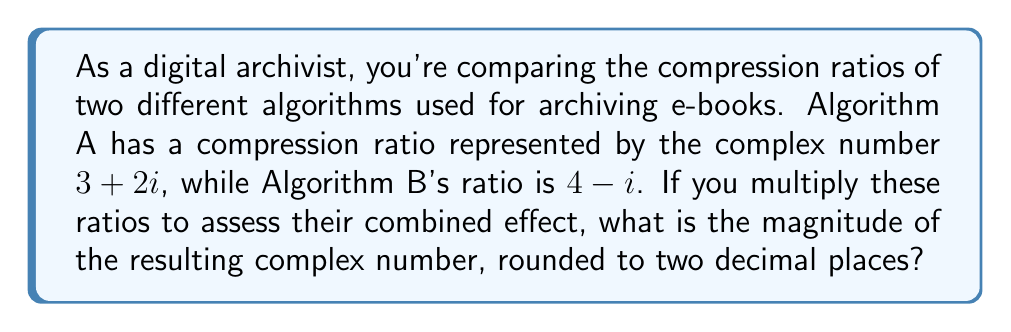Provide a solution to this math problem. To solve this problem, we'll follow these steps:

1) First, let's multiply the two complex numbers:
   $(3 + 2i)(4 - i)$

2) Using the FOIL method:
   $3(4) + 3(-i) + 2i(4) + 2i(-i)$
   $= 12 - 3i + 8i - 2i^2$

3) Simplify, noting that $i^2 = -1$:
   $12 - 3i + 8i + 2$
   $= 14 + 5i$

4) Now we have the resulting complex number: $14 + 5i$

5) To find its magnitude, we use the formula:
   $|a + bi| = \sqrt{a^2 + b^2}$

6) Substituting our values:
   $|14 + 5i| = \sqrt{14^2 + 5^2}$

7) Calculate:
   $\sqrt{196 + 25} = \sqrt{221}$

8) Use a calculator to compute and round to two decimal places:
   $\sqrt{221} \approx 14.87$

Thus, the magnitude of the resulting complex number, rounded to two decimal places, is 14.87.
Answer: 14.87 